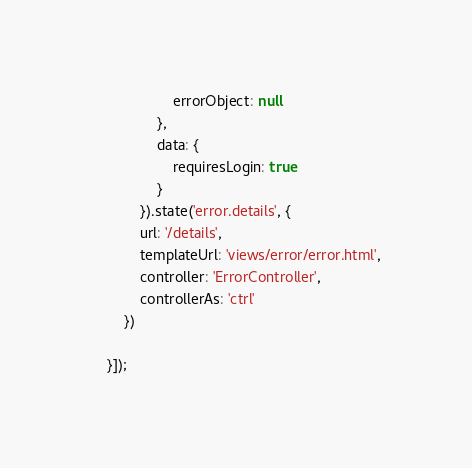<code> <loc_0><loc_0><loc_500><loc_500><_JavaScript_>                    errorObject: null
                },
                data: {
                    requiresLogin: true
                }
            }).state('error.details', {
            url: '/details',
            templateUrl: 'views/error/error.html',
            controller: 'ErrorController',
            controllerAs: 'ctrl'
        })

    }]);</code> 